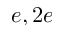Convert formula to latex. <formula><loc_0><loc_0><loc_500><loc_500>e , 2 e</formula> 